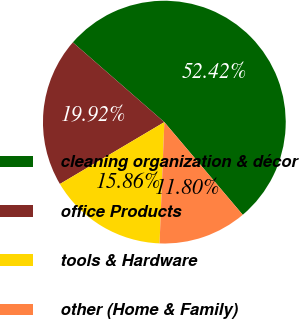<chart> <loc_0><loc_0><loc_500><loc_500><pie_chart><fcel>cleaning organization & décor<fcel>office Products<fcel>tools & Hardware<fcel>other (Home & Family)<nl><fcel>52.41%<fcel>19.92%<fcel>15.86%<fcel>11.8%<nl></chart> 